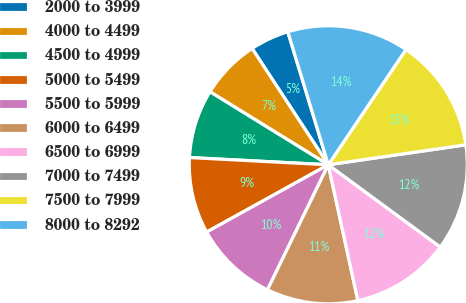<chart> <loc_0><loc_0><loc_500><loc_500><pie_chart><fcel>2000 to 3999<fcel>4000 to 4499<fcel>4500 to 4999<fcel>5000 to 5499<fcel>5500 to 5999<fcel>6000 to 6499<fcel>6500 to 6999<fcel>7000 to 7499<fcel>7500 to 7999<fcel>8000 to 8292<nl><fcel>4.53%<fcel>6.97%<fcel>7.97%<fcel>8.87%<fcel>9.75%<fcel>10.62%<fcel>11.5%<fcel>12.38%<fcel>13.26%<fcel>14.14%<nl></chart> 